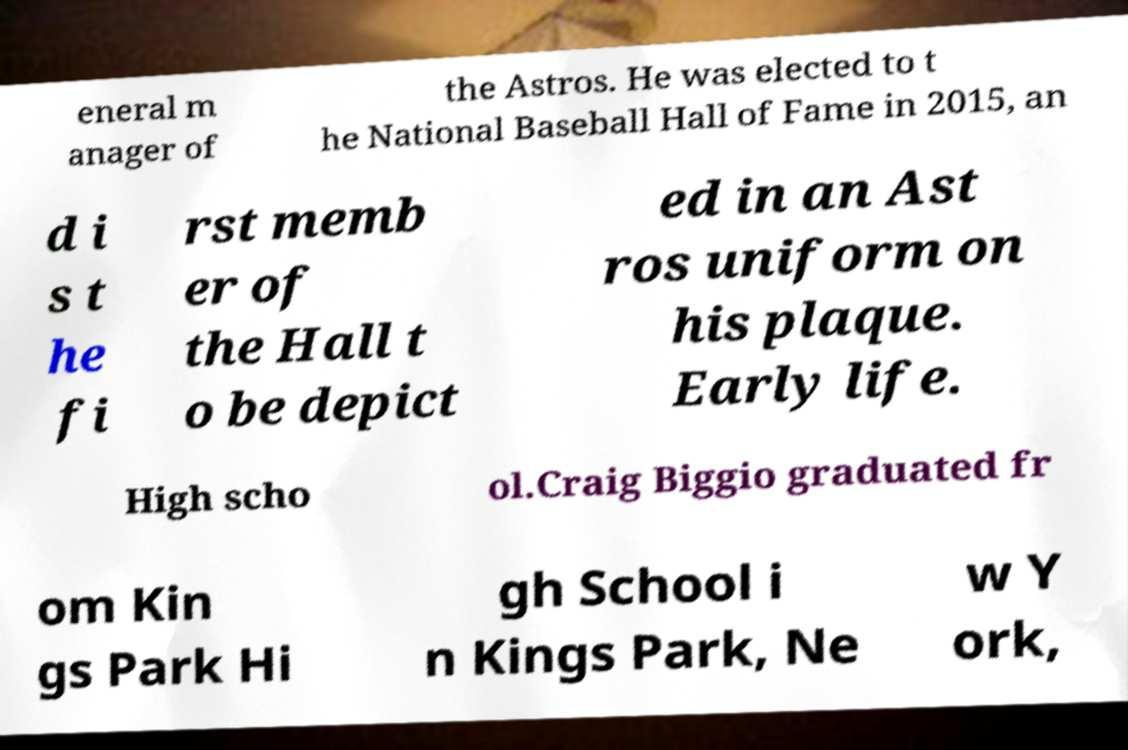For documentation purposes, I need the text within this image transcribed. Could you provide that? eneral m anager of the Astros. He was elected to t he National Baseball Hall of Fame in 2015, an d i s t he fi rst memb er of the Hall t o be depict ed in an Ast ros uniform on his plaque. Early life. High scho ol.Craig Biggio graduated fr om Kin gs Park Hi gh School i n Kings Park, Ne w Y ork, 